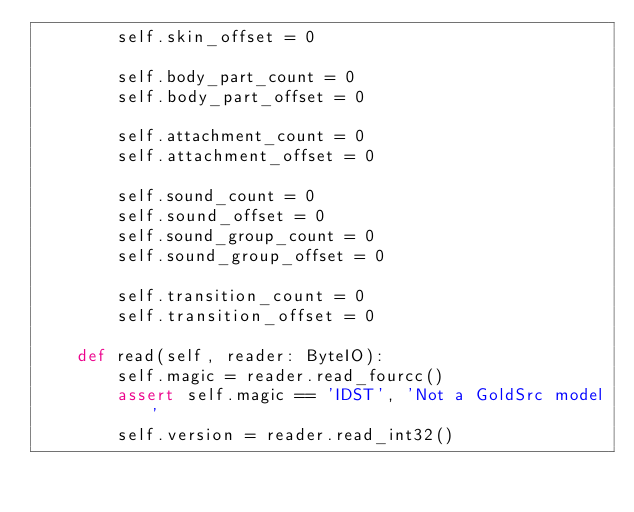Convert code to text. <code><loc_0><loc_0><loc_500><loc_500><_Python_>        self.skin_offset = 0

        self.body_part_count = 0
        self.body_part_offset = 0

        self.attachment_count = 0
        self.attachment_offset = 0

        self.sound_count = 0
        self.sound_offset = 0
        self.sound_group_count = 0
        self.sound_group_offset = 0

        self.transition_count = 0
        self.transition_offset = 0

    def read(self, reader: ByteIO):
        self.magic = reader.read_fourcc()
        assert self.magic == 'IDST', 'Not a GoldSrc model'
        self.version = reader.read_int32()</code> 